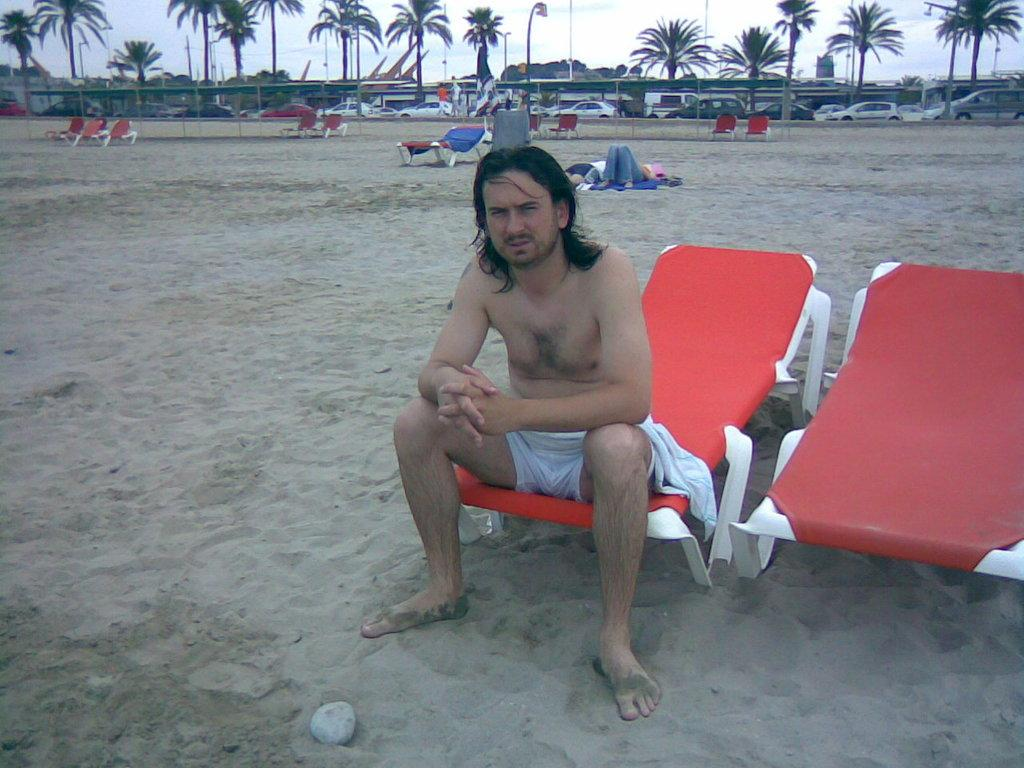What is the man in the image sitting on? There is a man sitting on a red chair in the image. What can be seen in the distance in the image? There are vehicles and trees visible in the distance. What type of smell can be detected coming from the man's feet in the image? There is no indication of any smell or the man's feet in the image, as it only shows the man sitting on a red chair and the distant view of vehicles and trees. 